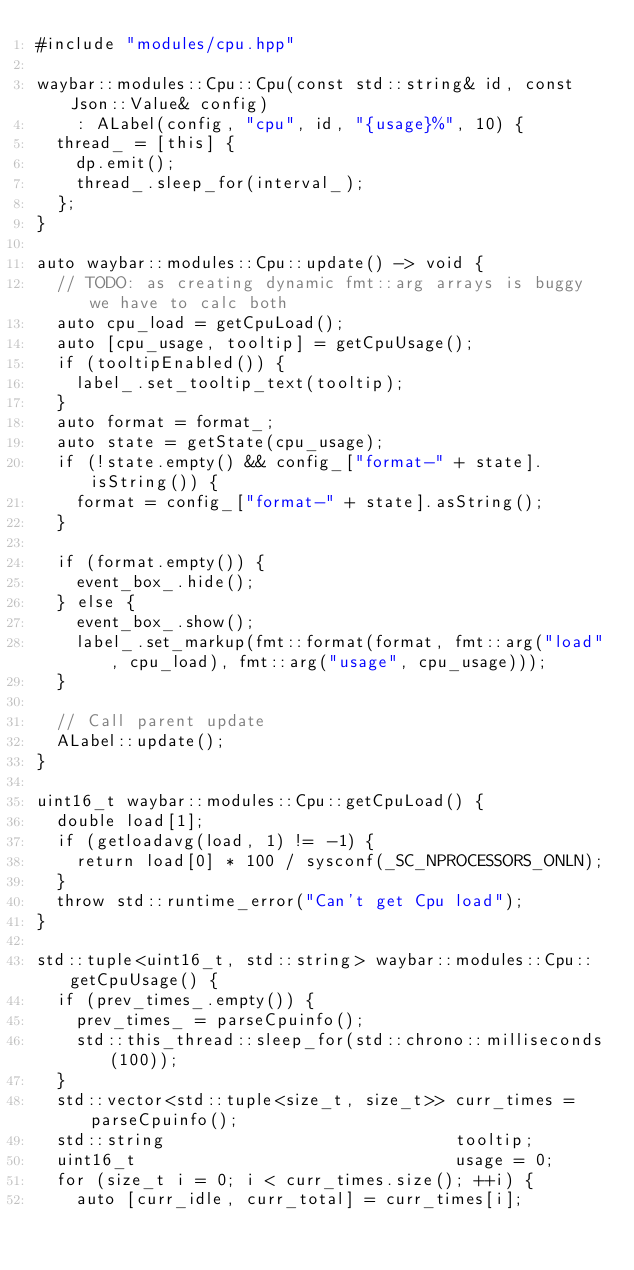Convert code to text. <code><loc_0><loc_0><loc_500><loc_500><_C++_>#include "modules/cpu.hpp"

waybar::modules::Cpu::Cpu(const std::string& id, const Json::Value& config)
    : ALabel(config, "cpu", id, "{usage}%", 10) {
  thread_ = [this] {
    dp.emit();
    thread_.sleep_for(interval_);
  };
}

auto waybar::modules::Cpu::update() -> void {
  // TODO: as creating dynamic fmt::arg arrays is buggy we have to calc both
  auto cpu_load = getCpuLoad();
  auto [cpu_usage, tooltip] = getCpuUsage();
  if (tooltipEnabled()) {
    label_.set_tooltip_text(tooltip);
  }
  auto format = format_;
  auto state = getState(cpu_usage);
  if (!state.empty() && config_["format-" + state].isString()) {
    format = config_["format-" + state].asString();
  }

  if (format.empty()) {
    event_box_.hide();
  } else {
    event_box_.show();
    label_.set_markup(fmt::format(format, fmt::arg("load", cpu_load), fmt::arg("usage", cpu_usage)));
  }

  // Call parent update
  ALabel::update();
}

uint16_t waybar::modules::Cpu::getCpuLoad() {
  double load[1];
  if (getloadavg(load, 1) != -1) {
    return load[0] * 100 / sysconf(_SC_NPROCESSORS_ONLN);
  }
  throw std::runtime_error("Can't get Cpu load");
}

std::tuple<uint16_t, std::string> waybar::modules::Cpu::getCpuUsage() {
  if (prev_times_.empty()) {
    prev_times_ = parseCpuinfo();
    std::this_thread::sleep_for(std::chrono::milliseconds(100));
  }
  std::vector<std::tuple<size_t, size_t>> curr_times = parseCpuinfo();
  std::string                             tooltip;
  uint16_t                                usage = 0;
  for (size_t i = 0; i < curr_times.size(); ++i) {
    auto [curr_idle, curr_total] = curr_times[i];</code> 